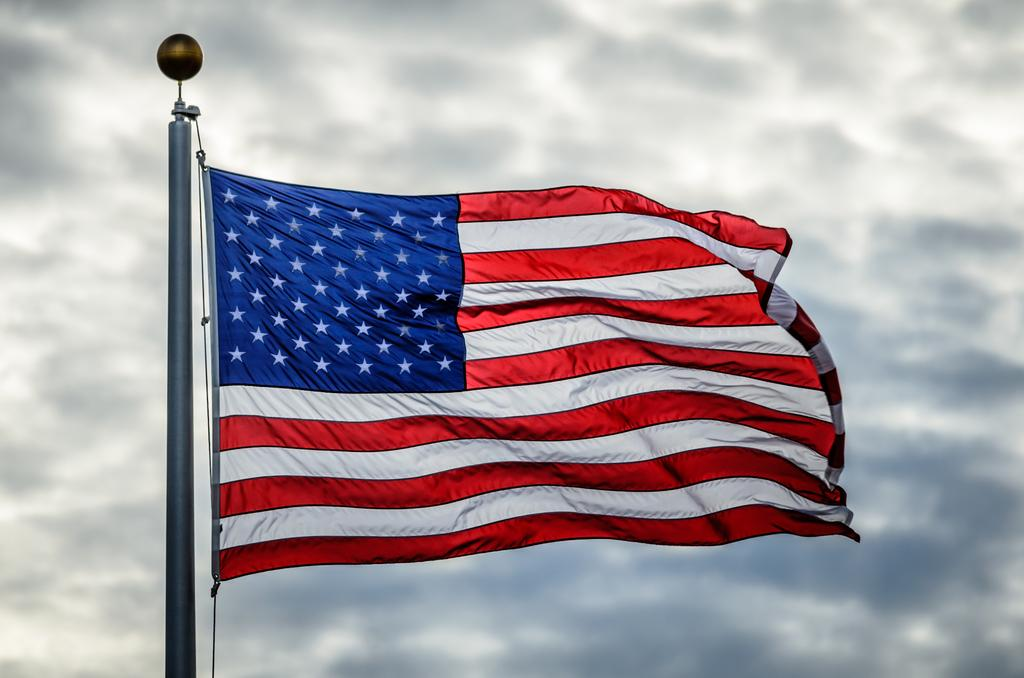What flag is visible in the image? There is a waving flag of the USA in the image. What is the flag attached to in the image? The flag is attached to a flagpole in the image. How would you describe the sky in the image? The sky is cloudy in the image. What type of box is being used to control the flag's movement in the image? There is no box or control mechanism present in the image; the flag is simply waving in the wind. 